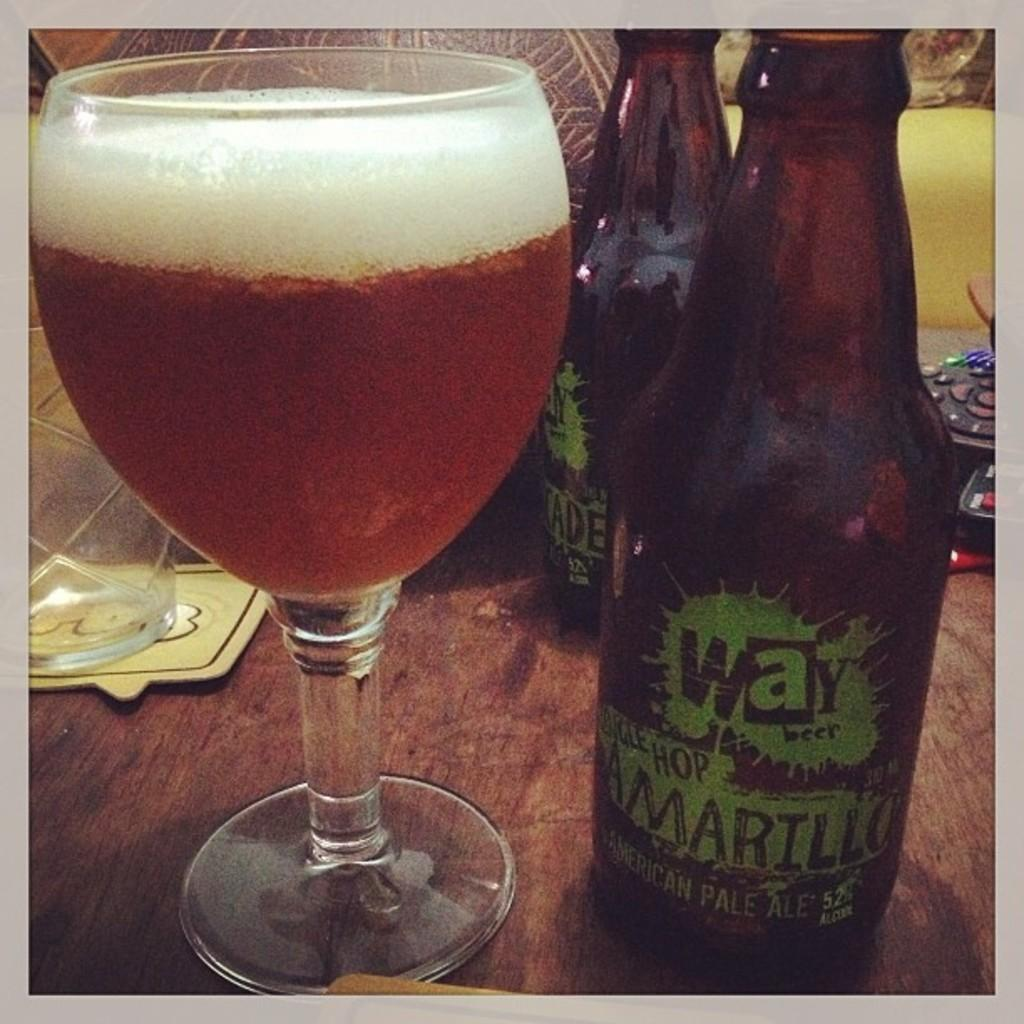<image>
Relay a brief, clear account of the picture shown. A bottle of a Amarillo Amarican pale ale beer next to a glass filled with it. 